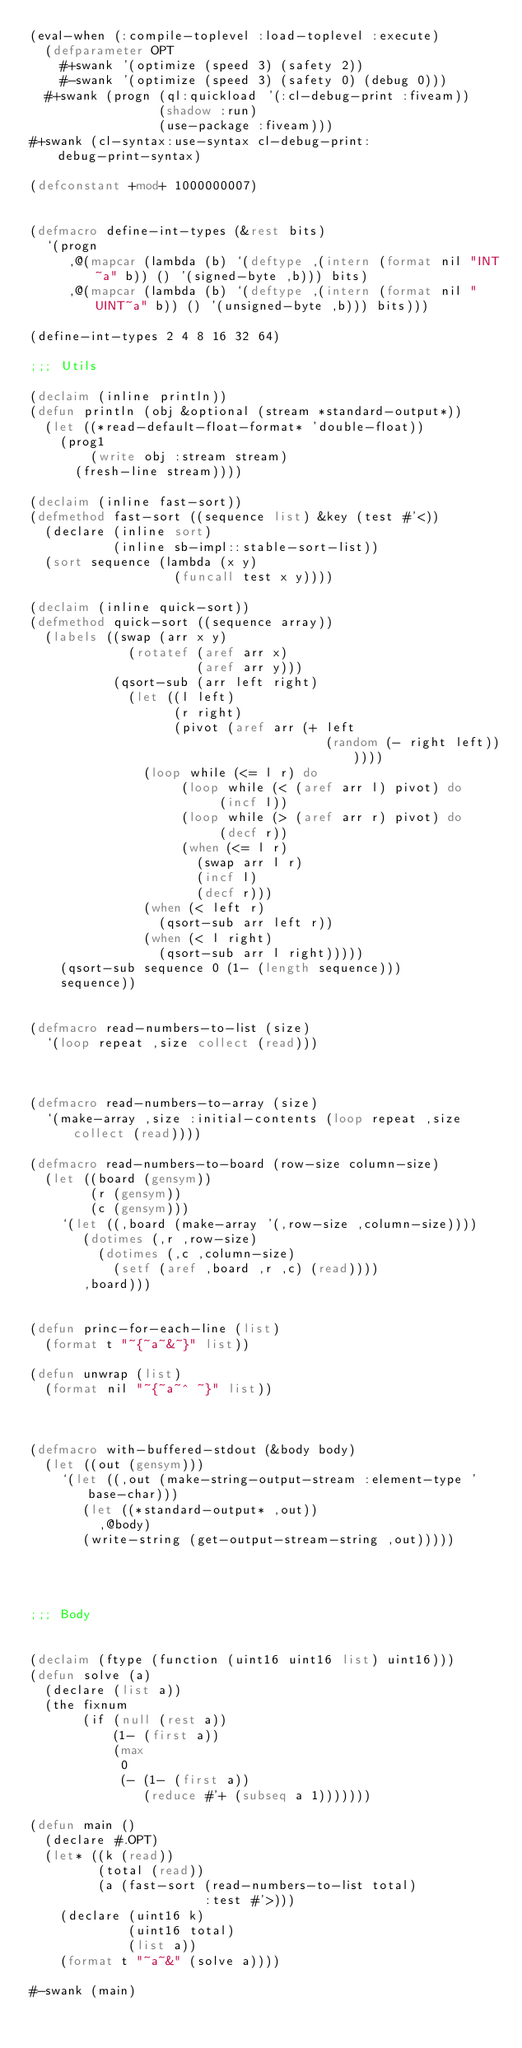Convert code to text. <code><loc_0><loc_0><loc_500><loc_500><_Lisp_>(eval-when (:compile-toplevel :load-toplevel :execute)
  (defparameter OPT
    #+swank '(optimize (speed 3) (safety 2))
    #-swank '(optimize (speed 3) (safety 0) (debug 0)))
  #+swank (progn (ql:quickload '(:cl-debug-print :fiveam))
                 (shadow :run)
                 (use-package :fiveam)))
#+swank (cl-syntax:use-syntax cl-debug-print:debug-print-syntax)

(defconstant +mod+ 1000000007)


(defmacro define-int-types (&rest bits)
  `(progn
     ,@(mapcar (lambda (b) `(deftype ,(intern (format nil "INT~a" b)) () '(signed-byte ,b))) bits)
     ,@(mapcar (lambda (b) `(deftype ,(intern (format nil "UINT~a" b)) () '(unsigned-byte ,b))) bits)))

(define-int-types 2 4 8 16 32 64)

;;; Utils

(declaim (inline println))
(defun println (obj &optional (stream *standard-output*))
  (let ((*read-default-float-format* 'double-float))
    (prog1
        (write obj :stream stream)
      (fresh-line stream))))

(declaim (inline fast-sort))
(defmethod fast-sort ((sequence list) &key (test #'<))
  (declare (inline sort)
           (inline sb-impl::stable-sort-list))
  (sort sequence (lambda (x y)
                   (funcall test x y))))

(declaim (inline quick-sort))
(defmethod quick-sort ((sequence array))
  (labels ((swap (arr x y)
             (rotatef (aref arr x)
                      (aref arr y)))
           (qsort-sub (arr left right)
             (let ((l left)
                   (r right)
                   (pivot (aref arr (+ left
                                       (random (- right left))))))
               (loop while (<= l r) do
                    (loop while (< (aref arr l) pivot) do
                         (incf l))
                    (loop while (> (aref arr r) pivot) do
                         (decf r))
                    (when (<= l r)
                      (swap arr l r)
                      (incf l)
                      (decf r)))
               (when (< left r)
                 (qsort-sub arr left r))
               (when (< l right)
                 (qsort-sub arr l right)))))
    (qsort-sub sequence 0 (1- (length sequence)))
    sequence))


(defmacro read-numbers-to-list (size)
  `(loop repeat ,size collect (read)))



(defmacro read-numbers-to-array (size)
  `(make-array ,size :initial-contents (loop repeat ,size collect (read))))

(defmacro read-numbers-to-board (row-size column-size)
  (let ((board (gensym))
        (r (gensym))
        (c (gensym)))
    `(let ((,board (make-array '(,row-size ,column-size))))
       (dotimes (,r ,row-size)
         (dotimes (,c ,column-size)
           (setf (aref ,board ,r ,c) (read))))
       ,board)))


(defun princ-for-each-line (list)
  (format t "~{~a~&~}" list))

(defun unwrap (list)
  (format nil "~{~a~^ ~}" list))



(defmacro with-buffered-stdout (&body body)
  (let ((out (gensym)))
    `(let ((,out (make-string-output-stream :element-type 'base-char)))
       (let ((*standard-output* ,out))
         ,@body)
       (write-string (get-output-stream-string ,out)))))




;;; Body


(declaim (ftype (function (uint16 uint16 list) uint16)))
(defun solve (a)
  (declare (list a))
  (the fixnum
       (if (null (rest a))
           (1- (first a))
           (max
            0
            (- (1- (first a))
               (reduce #'+ (subseq a 1)))))))

(defun main ()
  (declare #.OPT)
  (let* ((k (read))
         (total (read))
         (a (fast-sort (read-numbers-to-list total)
                       :test #'>)))
    (declare (uint16 k)
             (uint16 total)
             (list a))
    (format t "~a~&" (solve a))))

#-swank (main)
</code> 